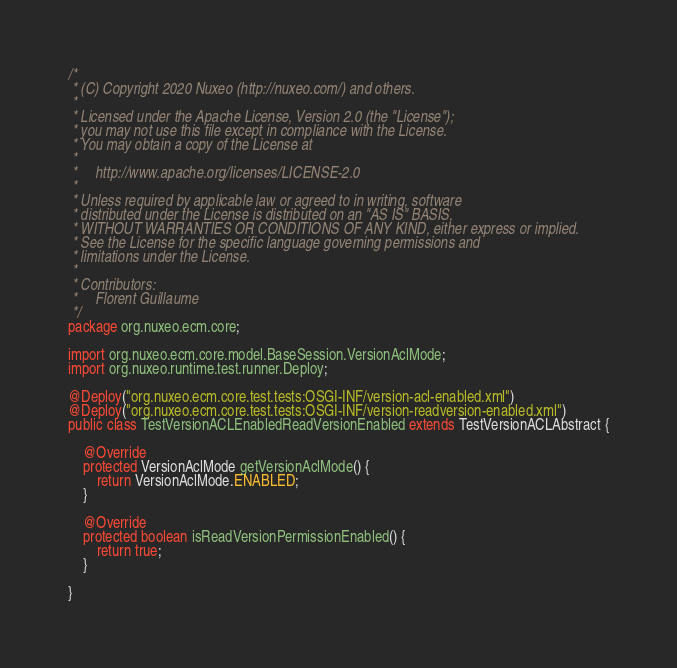<code> <loc_0><loc_0><loc_500><loc_500><_Java_>/*
 * (C) Copyright 2020 Nuxeo (http://nuxeo.com/) and others.
 *
 * Licensed under the Apache License, Version 2.0 (the "License");
 * you may not use this file except in compliance with the License.
 * You may obtain a copy of the License at
 *
 *     http://www.apache.org/licenses/LICENSE-2.0
 *
 * Unless required by applicable law or agreed to in writing, software
 * distributed under the License is distributed on an "AS IS" BASIS,
 * WITHOUT WARRANTIES OR CONDITIONS OF ANY KIND, either express or implied.
 * See the License for the specific language governing permissions and
 * limitations under the License.
 *
 * Contributors:
 *     Florent Guillaume
 */
package org.nuxeo.ecm.core;

import org.nuxeo.ecm.core.model.BaseSession.VersionAclMode;
import org.nuxeo.runtime.test.runner.Deploy;

@Deploy("org.nuxeo.ecm.core.test.tests:OSGI-INF/version-acl-enabled.xml")
@Deploy("org.nuxeo.ecm.core.test.tests:OSGI-INF/version-readversion-enabled.xml")
public class TestVersionACLEnabledReadVersionEnabled extends TestVersionACLAbstract {

    @Override
    protected VersionAclMode getVersionAclMode() {
        return VersionAclMode.ENABLED;
    }

    @Override
    protected boolean isReadVersionPermissionEnabled() {
        return true;
    }

}
</code> 